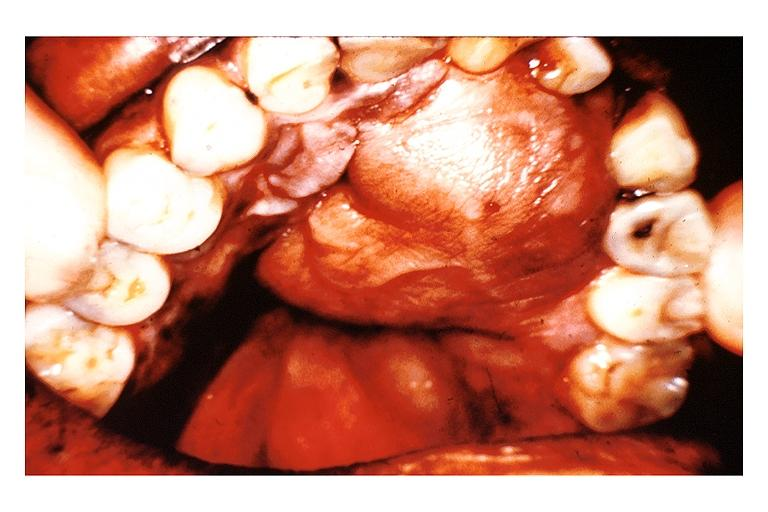what does this image show?
Answer the question using a single word or phrase. Neurofibroma 